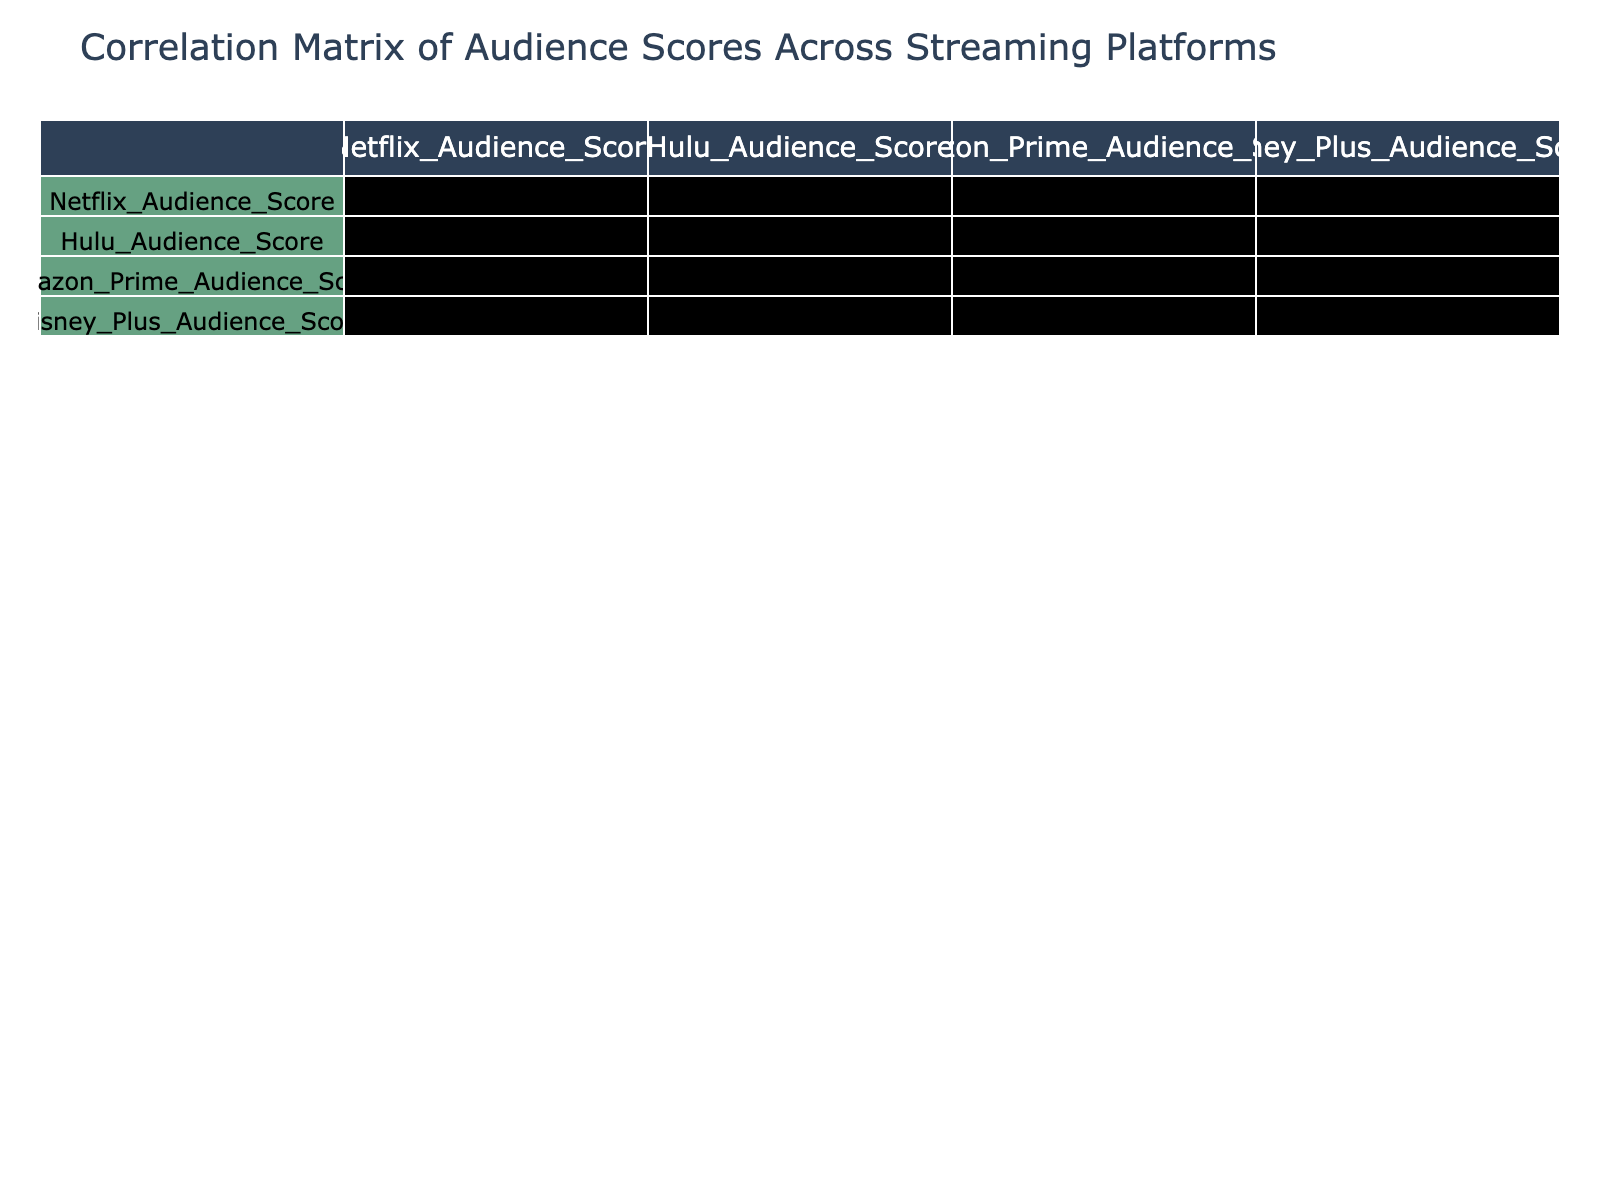What is the audience score for Action films on Netflix? The table indicates a score of 76 for Action films on Netflix. This value is directly taken from the corresponding cell in the "Netflix_Audience_Score" column under the "Action" genre row.
Answer: 76 Which genre has the highest audience score on Disney Plus? By reviewing the Disney Plus audience scores, Animation scores 95, which is the highest compared to other genres listed. It is taken from the "Disney_Plus_Audience_Score" column.
Answer: Animation What is the correlation between the audience scores on Netflix and Hulu? The correlation value between Netflix and Hulu audience scores, as seen in the correlation table, is 0.82. This indicates a strong positive correlation between these two streaming platforms.
Answer: 0.82 How does the average audience score for Comedy compare to Horror across all platforms? First, we calculate the average audience score for Comedy: (78 + 80 + 75 + 90) / 4 = 80.75. Next, we do the same for Horror: (70 + 75 + 72 + 80) / 4 = 74.25. Finally, comparing the two, Comedy scores higher than Horror by 80.75 - 74.25 = 6.5.
Answer: Comedy scores higher by 6.5 Is there a genre where the audience scores are consistently above 80 across all platforms? Examining the data, Animation is the only genre with audience scores above 80 on all platforms: 90 (Netflix), 87 (Hulu), 85 (Amazon Prime), and 95 (Disney Plus). Therefore, the answer is yes.
Answer: Yes 